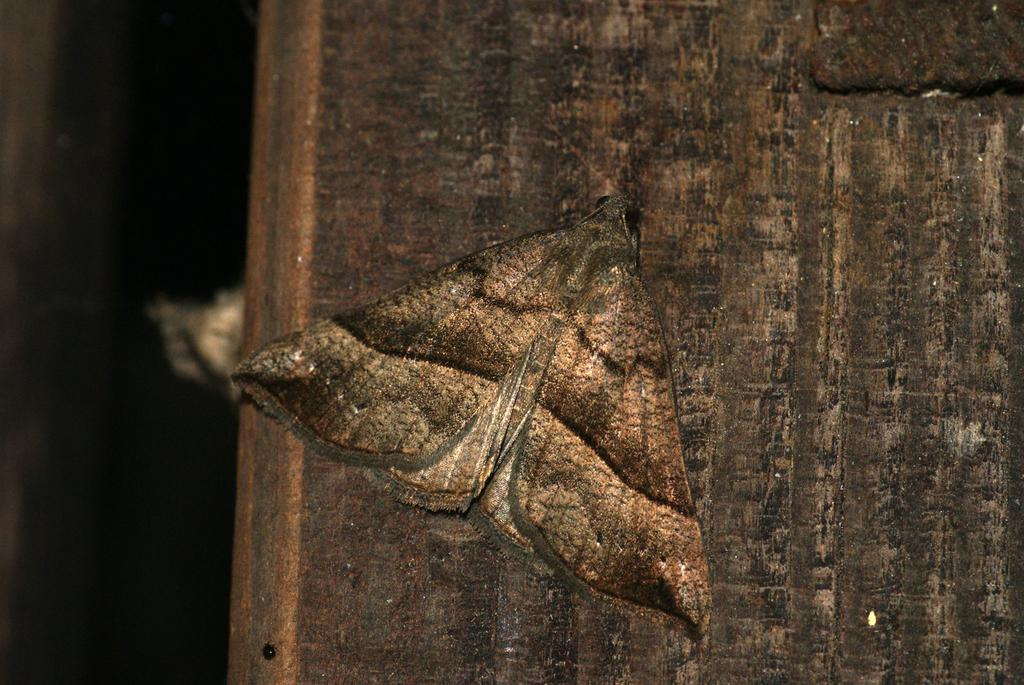What is the main subject of the image? The main subject of the image is a butterfly. Where is the butterfly located in the image? The butterfly is on a wooden surface. What type of gold can be seen on the butterfly in the image? There is no gold present on the butterfly in the image. What type of berry is the butterfly eating in the image? There is no berry present in the image, and the butterfly is not shown eating anything. 